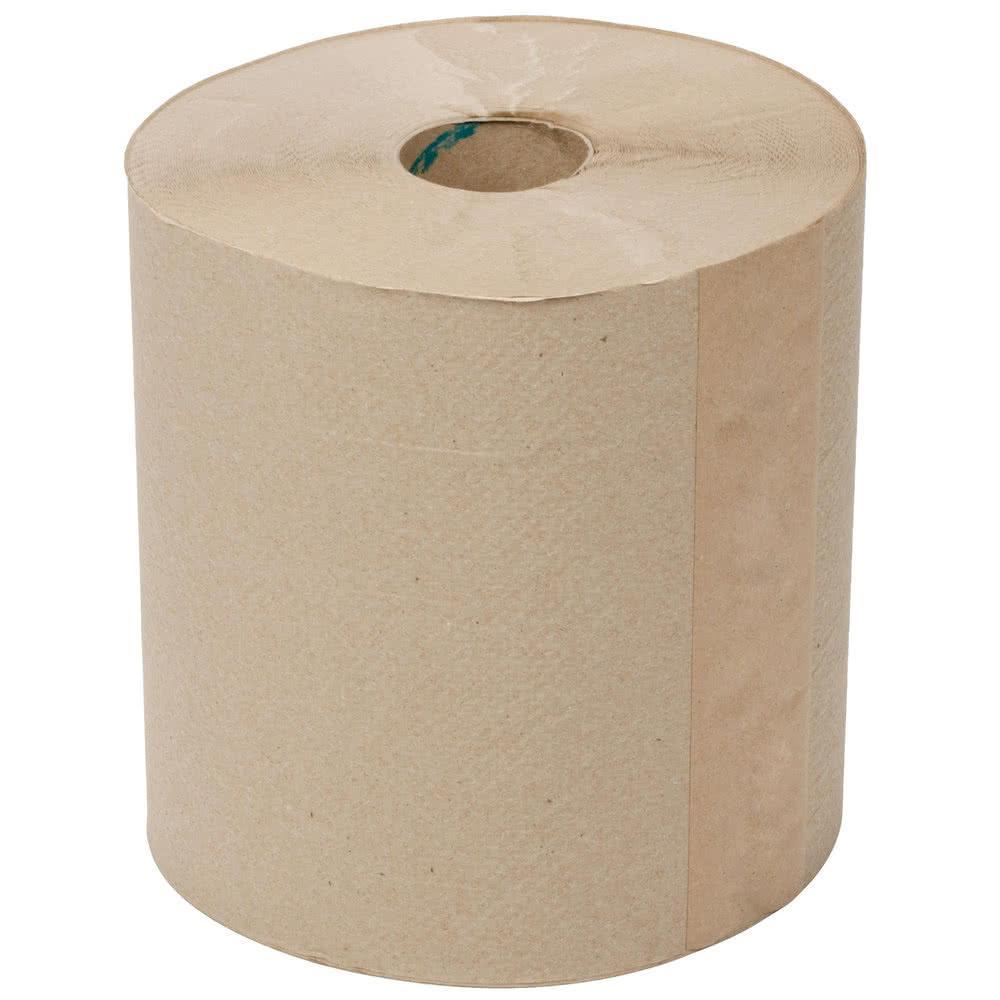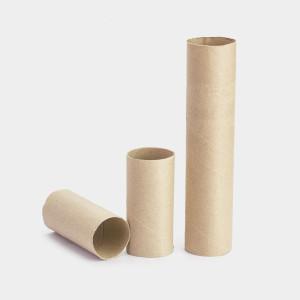The first image is the image on the left, the second image is the image on the right. For the images shown, is this caption "An image features one upright towel row the color of brown kraft paper." true? Answer yes or no. Yes. The first image is the image on the left, the second image is the image on the right. Analyze the images presented: Is the assertion "The roll of paper in one of the image is brown." valid? Answer yes or no. Yes. 